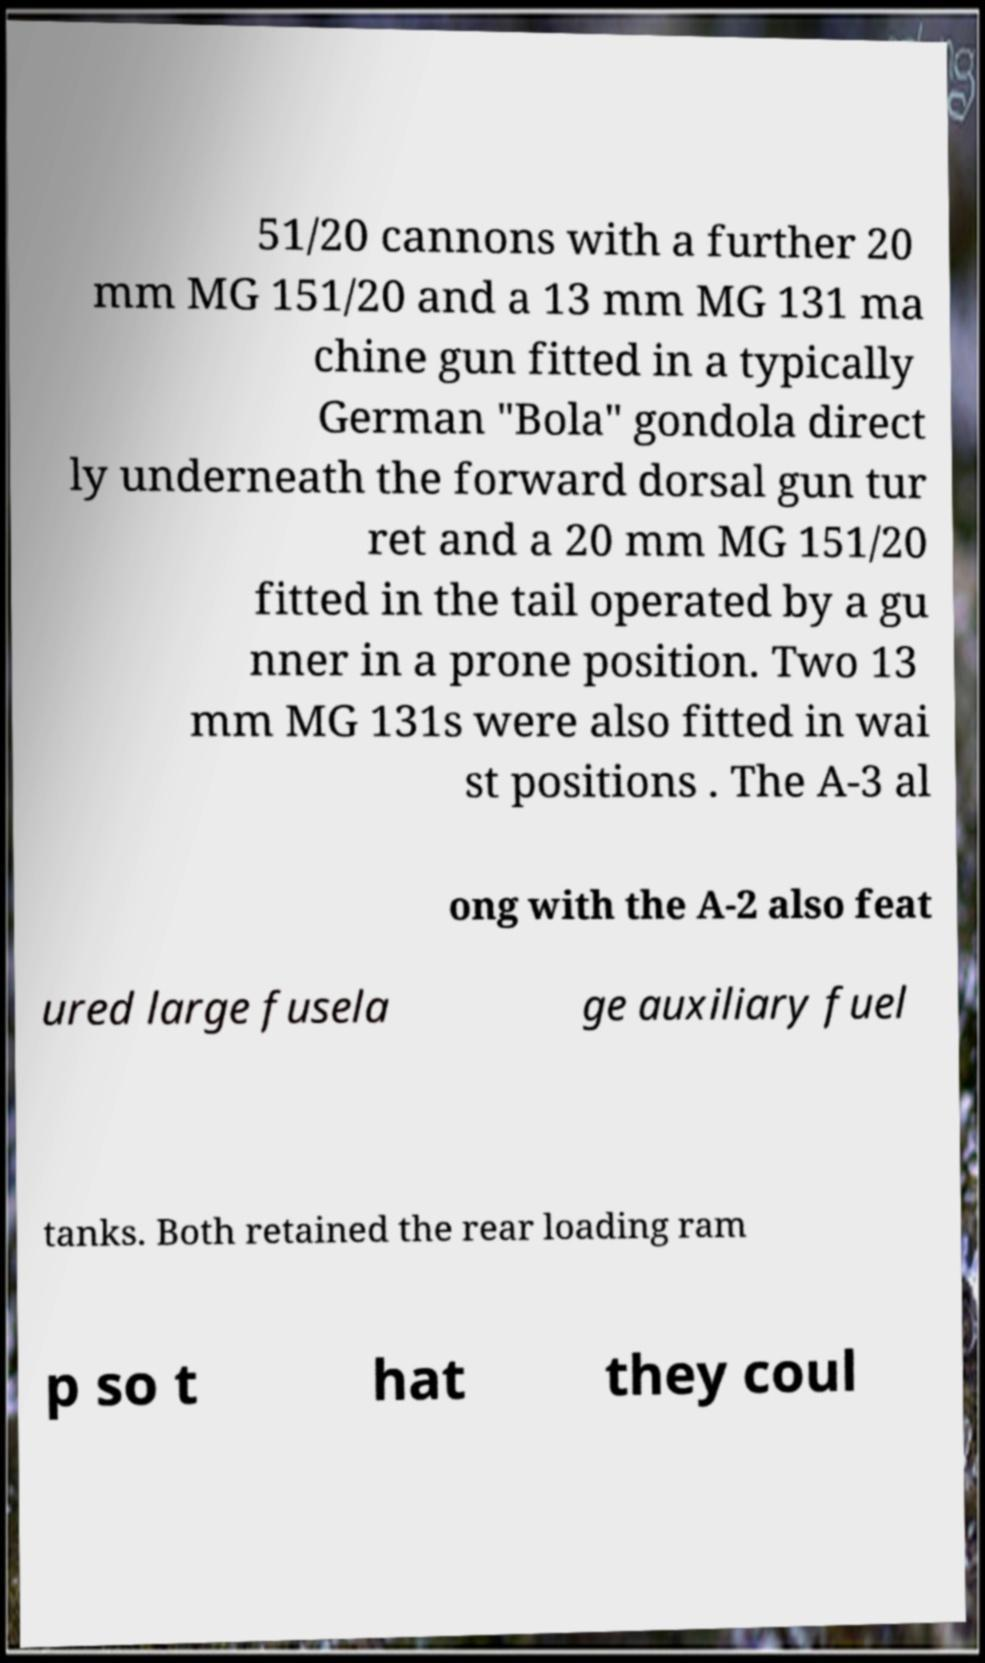There's text embedded in this image that I need extracted. Can you transcribe it verbatim? 51/20 cannons with a further 20 mm MG 151/20 and a 13 mm MG 131 ma chine gun fitted in a typically German "Bola" gondola direct ly underneath the forward dorsal gun tur ret and a 20 mm MG 151/20 fitted in the tail operated by a gu nner in a prone position. Two 13 mm MG 131s were also fitted in wai st positions . The A-3 al ong with the A-2 also feat ured large fusela ge auxiliary fuel tanks. Both retained the rear loading ram p so t hat they coul 